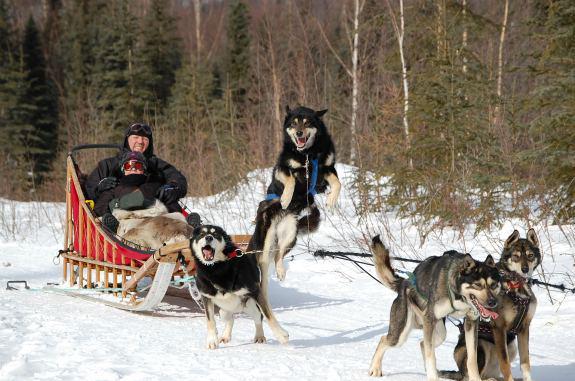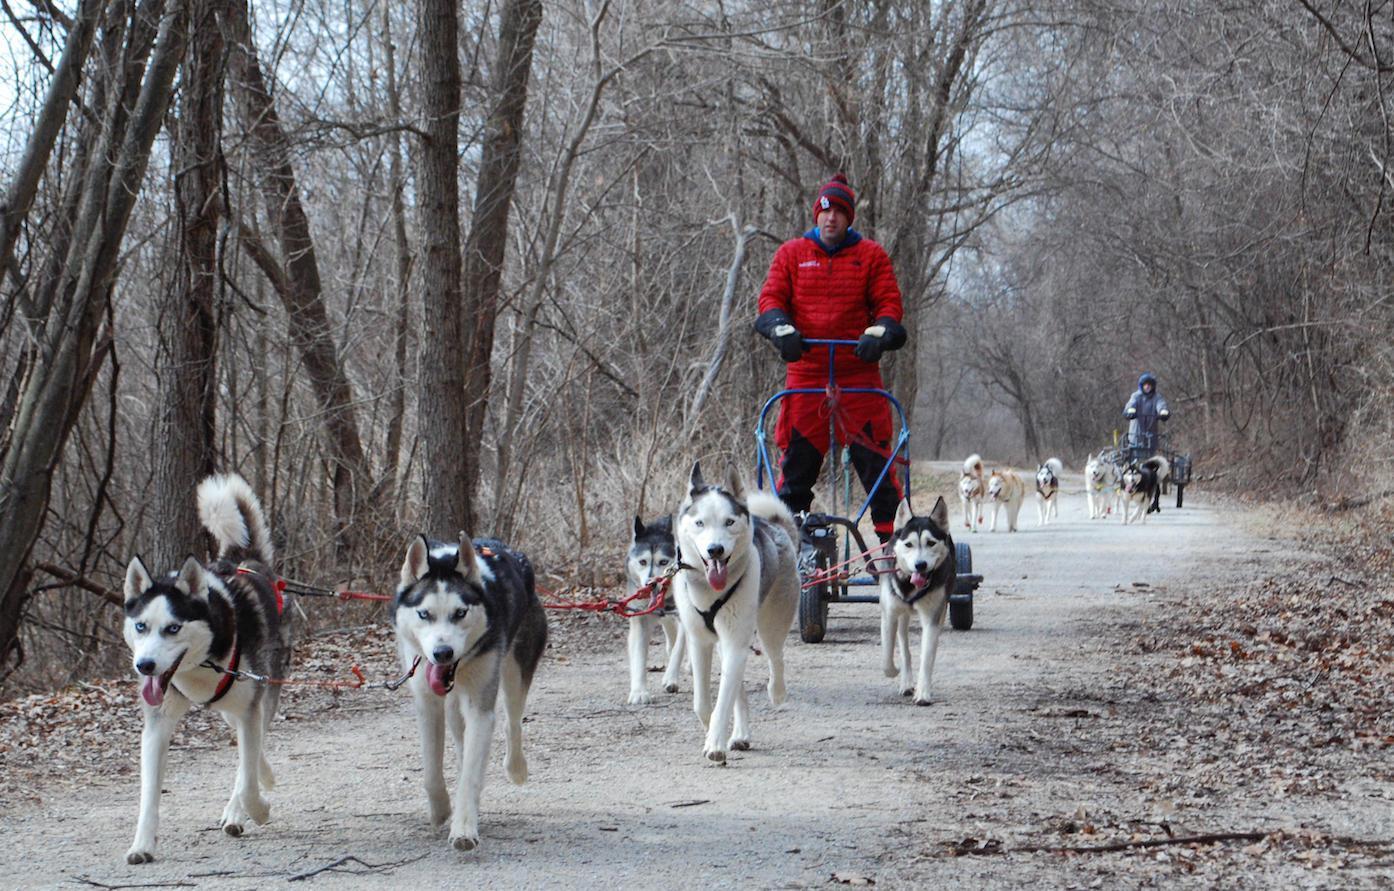The first image is the image on the left, the second image is the image on the right. Analyze the images presented: Is the assertion "One dog is sitting." valid? Answer yes or no. Yes. The first image is the image on the left, the second image is the image on the right. Evaluate the accuracy of this statement regarding the images: "The dog sled teams in the left and right images appear to be heading toward each other.". Is it true? Answer yes or no. Yes. 